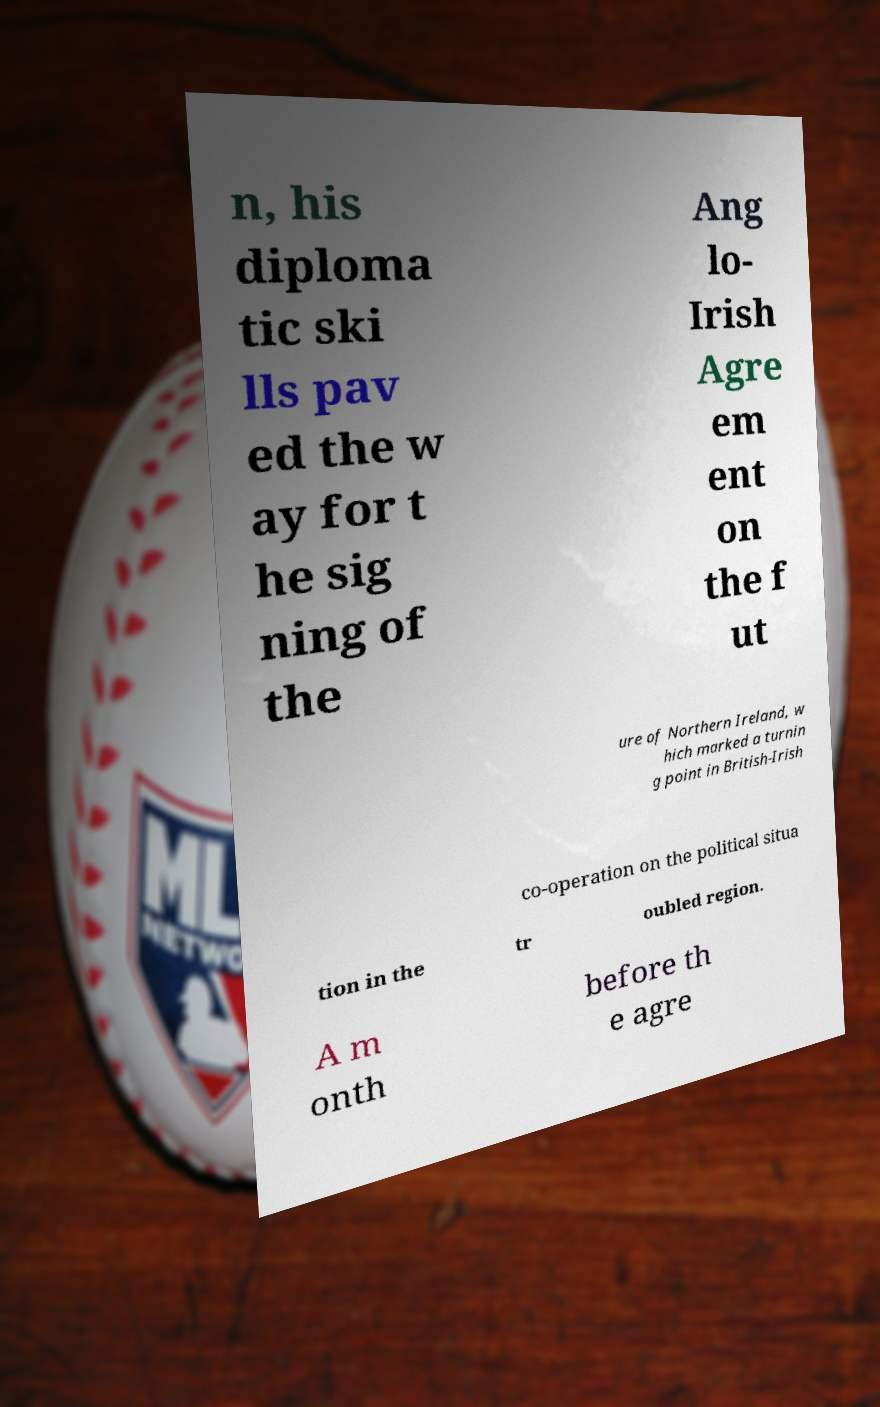For documentation purposes, I need the text within this image transcribed. Could you provide that? n, his diploma tic ski lls pav ed the w ay for t he sig ning of the Ang lo- Irish Agre em ent on the f ut ure of Northern Ireland, w hich marked a turnin g point in British-Irish co-operation on the political situa tion in the tr oubled region. A m onth before th e agre 